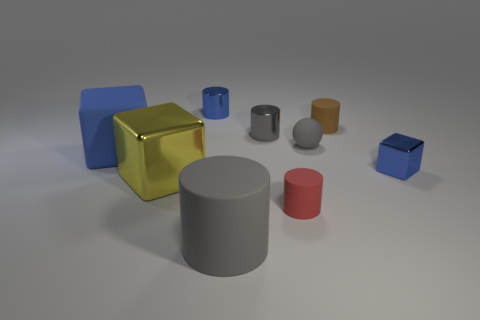Subtract all red cylinders. How many cylinders are left? 4 Subtract all purple cylinders. Subtract all yellow blocks. How many cylinders are left? 5 Subtract all spheres. How many objects are left? 8 Add 4 tiny brown cylinders. How many tiny brown cylinders exist? 5 Subtract 0 purple cubes. How many objects are left? 9 Subtract all large red metal cubes. Subtract all tiny red objects. How many objects are left? 8 Add 9 small red objects. How many small red objects are left? 10 